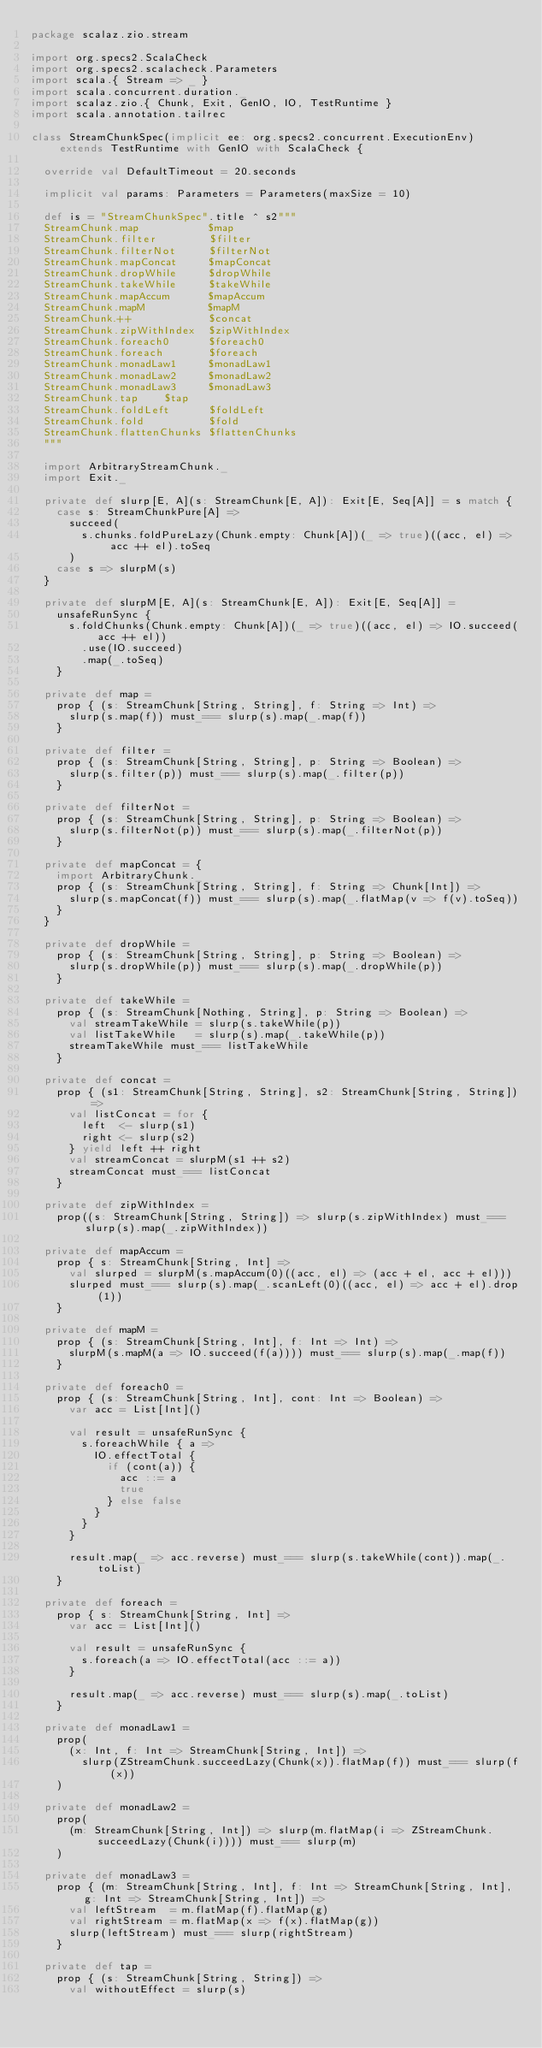<code> <loc_0><loc_0><loc_500><loc_500><_Scala_>package scalaz.zio.stream

import org.specs2.ScalaCheck
import org.specs2.scalacheck.Parameters
import scala.{ Stream => _ }
import scala.concurrent.duration._
import scalaz.zio.{ Chunk, Exit, GenIO, IO, TestRuntime }
import scala.annotation.tailrec

class StreamChunkSpec(implicit ee: org.specs2.concurrent.ExecutionEnv) extends TestRuntime with GenIO with ScalaCheck {

  override val DefaultTimeout = 20.seconds

  implicit val params: Parameters = Parameters(maxSize = 10)

  def is = "StreamChunkSpec".title ^ s2"""
  StreamChunk.map           $map
  StreamChunk.filter        $filter
  StreamChunk.filterNot     $filterNot
  StreamChunk.mapConcat     $mapConcat
  StreamChunk.dropWhile     $dropWhile
  StreamChunk.takeWhile     $takeWhile
  StreamChunk.mapAccum      $mapAccum
  StreamChunk.mapM          $mapM
  StreamChunk.++            $concat
  StreamChunk.zipWithIndex  $zipWithIndex
  StreamChunk.foreach0      $foreach0
  StreamChunk.foreach       $foreach
  StreamChunk.monadLaw1     $monadLaw1
  StreamChunk.monadLaw2     $monadLaw2
  StreamChunk.monadLaw3     $monadLaw3
  StreamChunk.tap    $tap
  StreamChunk.foldLeft      $foldLeft
  StreamChunk.fold          $fold    
  StreamChunk.flattenChunks $flattenChunks
  """

  import ArbitraryStreamChunk._
  import Exit._

  private def slurp[E, A](s: StreamChunk[E, A]): Exit[E, Seq[A]] = s match {
    case s: StreamChunkPure[A] =>
      succeed(
        s.chunks.foldPureLazy(Chunk.empty: Chunk[A])(_ => true)((acc, el) => acc ++ el).toSeq
      )
    case s => slurpM(s)
  }

  private def slurpM[E, A](s: StreamChunk[E, A]): Exit[E, Seq[A]] =
    unsafeRunSync {
      s.foldChunks(Chunk.empty: Chunk[A])(_ => true)((acc, el) => IO.succeed(acc ++ el))
        .use(IO.succeed)
        .map(_.toSeq)
    }

  private def map =
    prop { (s: StreamChunk[String, String], f: String => Int) =>
      slurp(s.map(f)) must_=== slurp(s).map(_.map(f))
    }

  private def filter =
    prop { (s: StreamChunk[String, String], p: String => Boolean) =>
      slurp(s.filter(p)) must_=== slurp(s).map(_.filter(p))
    }

  private def filterNot =
    prop { (s: StreamChunk[String, String], p: String => Boolean) =>
      slurp(s.filterNot(p)) must_=== slurp(s).map(_.filterNot(p))
    }

  private def mapConcat = {
    import ArbitraryChunk._
    prop { (s: StreamChunk[String, String], f: String => Chunk[Int]) =>
      slurp(s.mapConcat(f)) must_=== slurp(s).map(_.flatMap(v => f(v).toSeq))
    }
  }

  private def dropWhile =
    prop { (s: StreamChunk[String, String], p: String => Boolean) =>
      slurp(s.dropWhile(p)) must_=== slurp(s).map(_.dropWhile(p))
    }

  private def takeWhile =
    prop { (s: StreamChunk[Nothing, String], p: String => Boolean) =>
      val streamTakeWhile = slurp(s.takeWhile(p))
      val listTakeWhile   = slurp(s).map(_.takeWhile(p))
      streamTakeWhile must_=== listTakeWhile
    }

  private def concat =
    prop { (s1: StreamChunk[String, String], s2: StreamChunk[String, String]) =>
      val listConcat = for {
        left  <- slurp(s1)
        right <- slurp(s2)
      } yield left ++ right
      val streamConcat = slurpM(s1 ++ s2)
      streamConcat must_=== listConcat
    }

  private def zipWithIndex =
    prop((s: StreamChunk[String, String]) => slurp(s.zipWithIndex) must_=== slurp(s).map(_.zipWithIndex))

  private def mapAccum =
    prop { s: StreamChunk[String, Int] =>
      val slurped = slurpM(s.mapAccum(0)((acc, el) => (acc + el, acc + el)))
      slurped must_=== slurp(s).map(_.scanLeft(0)((acc, el) => acc + el).drop(1))
    }

  private def mapM =
    prop { (s: StreamChunk[String, Int], f: Int => Int) =>
      slurpM(s.mapM(a => IO.succeed(f(a)))) must_=== slurp(s).map(_.map(f))
    }

  private def foreach0 =
    prop { (s: StreamChunk[String, Int], cont: Int => Boolean) =>
      var acc = List[Int]()

      val result = unsafeRunSync {
        s.foreachWhile { a =>
          IO.effectTotal {
            if (cont(a)) {
              acc ::= a
              true
            } else false
          }
        }
      }

      result.map(_ => acc.reverse) must_=== slurp(s.takeWhile(cont)).map(_.toList)
    }

  private def foreach =
    prop { s: StreamChunk[String, Int] =>
      var acc = List[Int]()

      val result = unsafeRunSync {
        s.foreach(a => IO.effectTotal(acc ::= a))
      }

      result.map(_ => acc.reverse) must_=== slurp(s).map(_.toList)
    }

  private def monadLaw1 =
    prop(
      (x: Int, f: Int => StreamChunk[String, Int]) =>
        slurp(ZStreamChunk.succeedLazy(Chunk(x)).flatMap(f)) must_=== slurp(f(x))
    )

  private def monadLaw2 =
    prop(
      (m: StreamChunk[String, Int]) => slurp(m.flatMap(i => ZStreamChunk.succeedLazy(Chunk(i)))) must_=== slurp(m)
    )

  private def monadLaw3 =
    prop { (m: StreamChunk[String, Int], f: Int => StreamChunk[String, Int], g: Int => StreamChunk[String, Int]) =>
      val leftStream  = m.flatMap(f).flatMap(g)
      val rightStream = m.flatMap(x => f(x).flatMap(g))
      slurp(leftStream) must_=== slurp(rightStream)
    }

  private def tap =
    prop { (s: StreamChunk[String, String]) =>
      val withoutEffect = slurp(s)</code> 